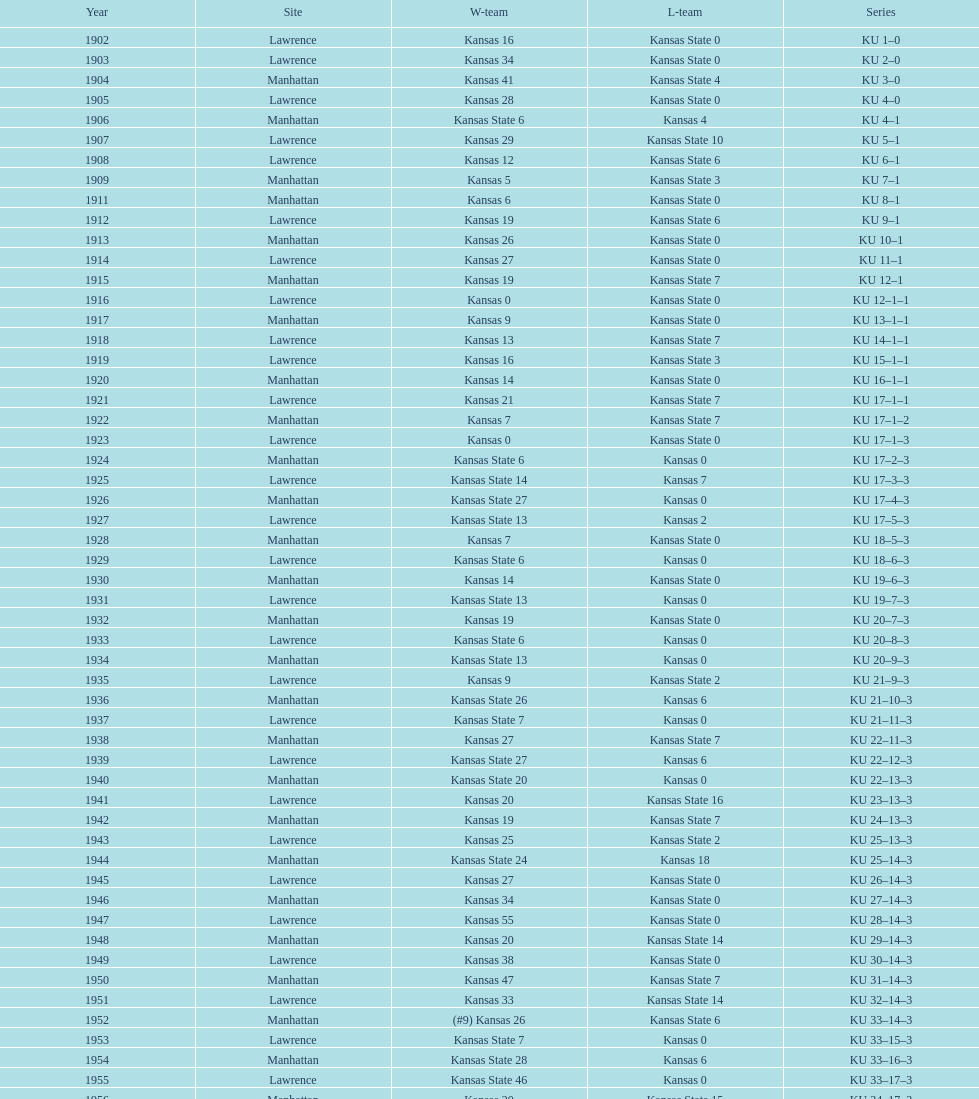What was the number of wins kansas state had in manhattan? 8. 